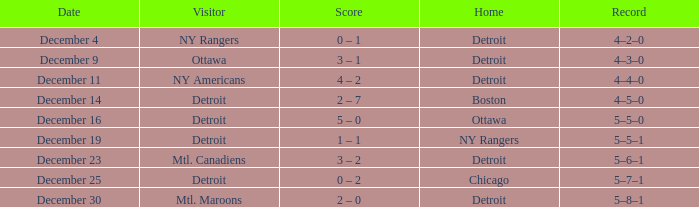What score has mtl. maroons as the visitor? 2 – 0. Could you parse the entire table? {'header': ['Date', 'Visitor', 'Score', 'Home', 'Record'], 'rows': [['December 4', 'NY Rangers', '0 – 1', 'Detroit', '4–2–0'], ['December 9', 'Ottawa', '3 – 1', 'Detroit', '4–3–0'], ['December 11', 'NY Americans', '4 – 2', 'Detroit', '4–4–0'], ['December 14', 'Detroit', '2 – 7', 'Boston', '4–5–0'], ['December 16', 'Detroit', '5 – 0', 'Ottawa', '5–5–0'], ['December 19', 'Detroit', '1 – 1', 'NY Rangers', '5–5–1'], ['December 23', 'Mtl. Canadiens', '3 – 2', 'Detroit', '5–6–1'], ['December 25', 'Detroit', '0 – 2', 'Chicago', '5–7–1'], ['December 30', 'Mtl. Maroons', '2 – 0', 'Detroit', '5–8–1']]} 